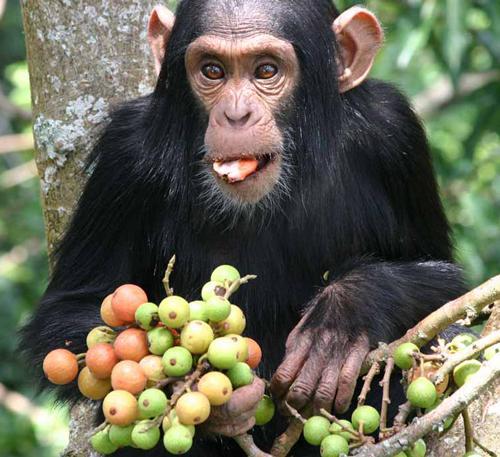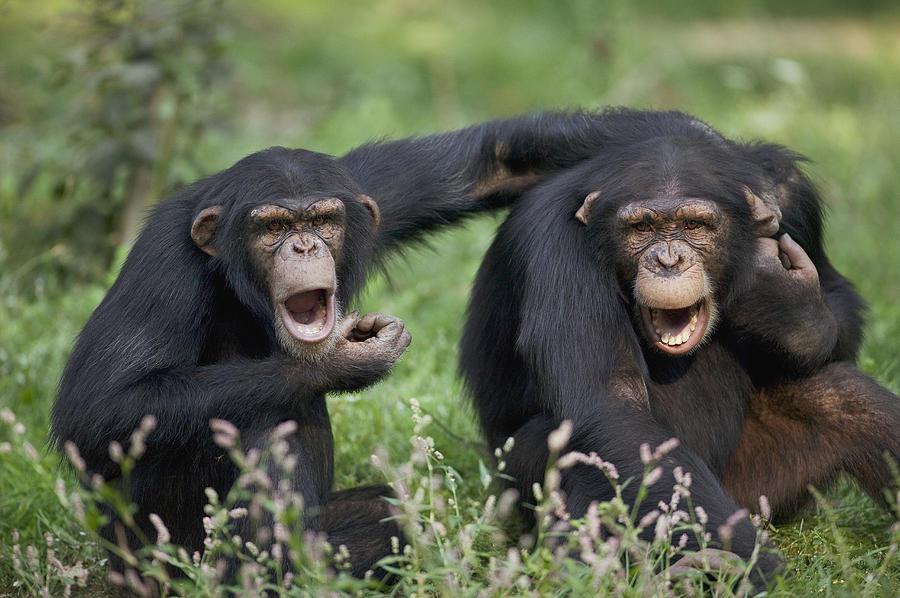The first image is the image on the left, the second image is the image on the right. Considering the images on both sides, is "The left image features exactly one chimpanzee." valid? Answer yes or no. Yes. The first image is the image on the left, the second image is the image on the right. Assess this claim about the two images: "The animal in the image on the left has its back to a tree.". Correct or not? Answer yes or no. Yes. 